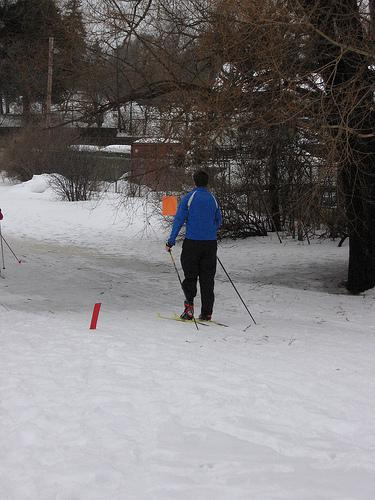Question: who is in the picture?
Choices:
A. A man.
B. My mother.
C. Her friend.
D. My dog.
Answer with the letter. Answer: A Question: when was this picture taken?
Choices:
A. Summer.
B. Winter.
C. Fall.
D. Spring.
Answer with the letter. Answer: B Question: what is the man doing?
Choices:
A. Skiing.
B. Snowboarding.
C. Drinking.
D. Eating.
Answer with the letter. Answer: A 